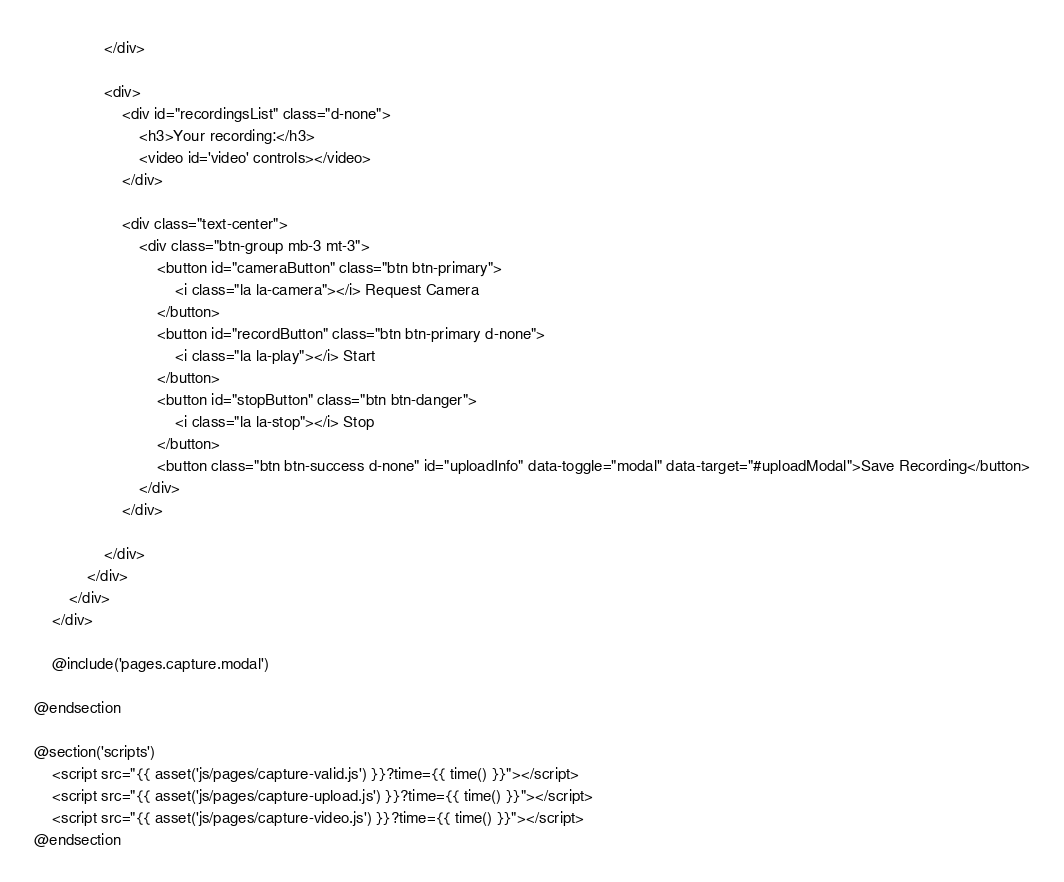<code> <loc_0><loc_0><loc_500><loc_500><_PHP_>                </div>

                <div>
                    <div id="recordingsList" class="d-none">
                        <h3>Your recording:</h3>
                        <video id='video' controls></video>
                    </div>

                    <div class="text-center">
                        <div class="btn-group mb-3 mt-3">
                            <button id="cameraButton" class="btn btn-primary">
                                <i class="la la-camera"></i> Request Camera
                            </button>
                            <button id="recordButton" class="btn btn-primary d-none">
                                <i class="la la-play"></i> Start
                            </button>
                            <button id="stopButton" class="btn btn-danger">
                                <i class="la la-stop"></i> Stop
                            </button>
                            <button class="btn btn-success d-none" id="uploadInfo" data-toggle="modal" data-target="#uploadModal">Save Recording</button>
                        </div>
                    </div>

                </div>
            </div>
        </div>
    </div>

    @include('pages.capture.modal')

@endsection

@section('scripts')
    <script src="{{ asset('js/pages/capture-valid.js') }}?time={{ time() }}"></script>
    <script src="{{ asset('js/pages/capture-upload.js') }}?time={{ time() }}"></script>
    <script src="{{ asset('js/pages/capture-video.js') }}?time={{ time() }}"></script>
@endsection
</code> 